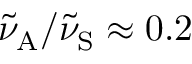<formula> <loc_0><loc_0><loc_500><loc_500>\tilde { \nu } _ { A } / \tilde { \nu } _ { S } \approx 0 . 2</formula> 